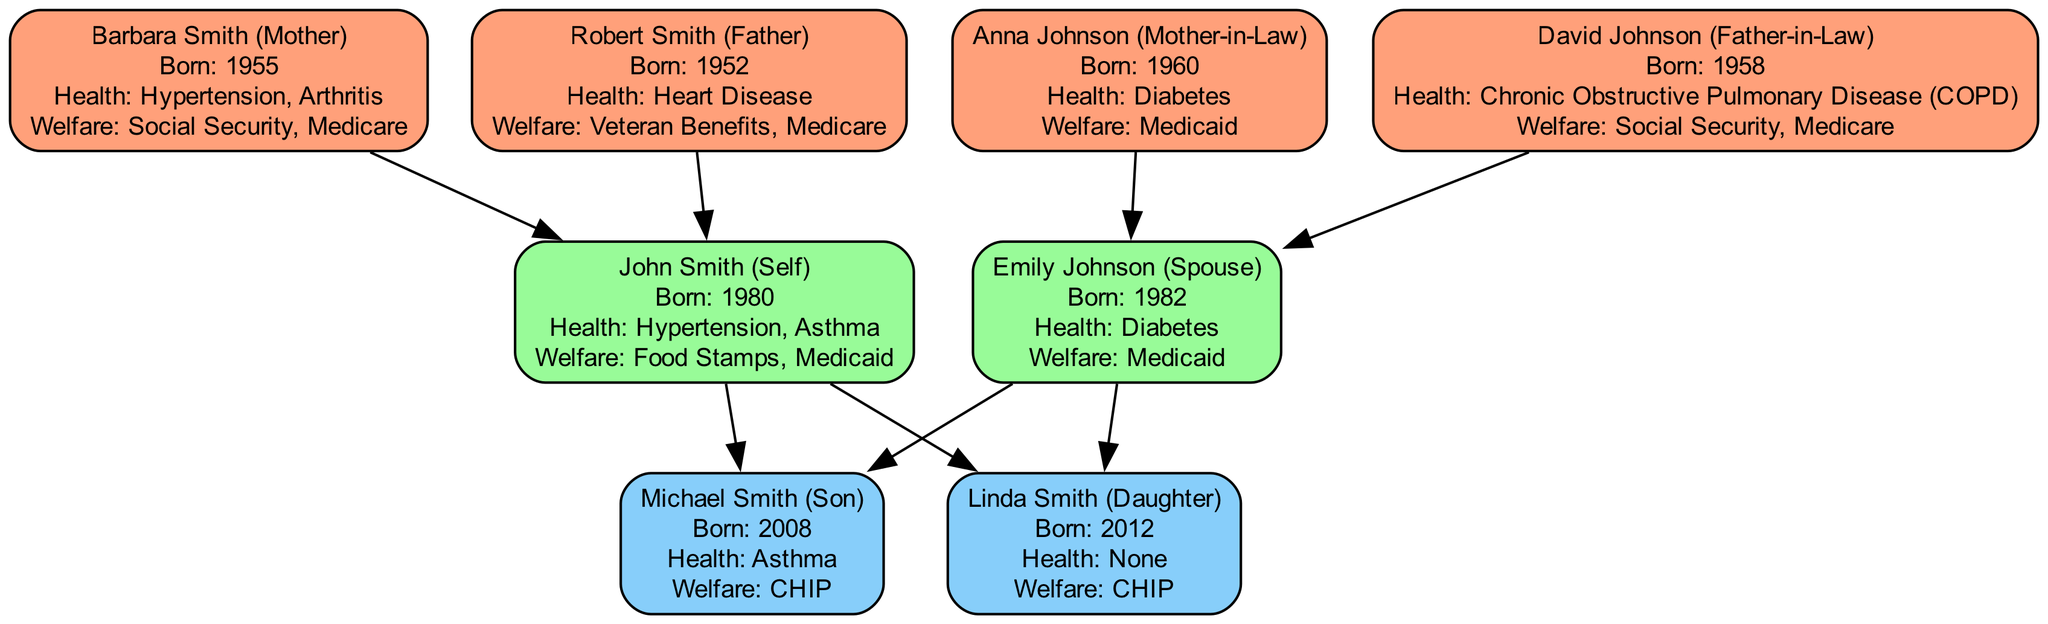What is the birth year of John Smith? The diagram shows that John Smith's information includes "Born: 1980," which indicates his birth year is 1980.
Answer: 1980 How many health conditions does Emily Johnson have? The diagram lists Emily Johnson's health conditions as "Diabetes," showing she has one health condition.
Answer: One Who supports Michael Smith with welfare? The welfare support for Michael Smith is indicated as "CHIP" in the diagram, identifying his welfare support type.
Answer: CHIP What relationship is Linda Smith to John Smith? The diagram directly connects Linda Smith to John Smith as "Daughter," clarifying their relationship.
Answer: Daughter Which elder family member has heart disease? The diagram identifies Robert Smith, who is labeled with "Heart Disease," making him the elder member with this condition.
Answer: Robert Smith How many edges are there connecting John Smith to his children? The diagram shows two edges going from John Smith to his children, Michael Smith and Linda Smith, indicating the number of connections.
Answer: Two What type of welfare support does Barbara Smith receive? The diagram states that Barbara Smith is supported by "Social Security" and "Medicare," specifying the types of welfare she receives.
Answer: Social Security, Medicare Which family member has the same health condition as John Smith? The diagram shows that both John Smith and Michael Smith have "Asthma" listed in their health conditions, indicating they share this condition.
Answer: Michael Smith What is the birth year of Anna Johnson? Anna Johnson's information in the diagram states "Born: 1960," which specifies her birth year.
Answer: 1960 